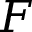<formula> <loc_0><loc_0><loc_500><loc_500>F</formula> 